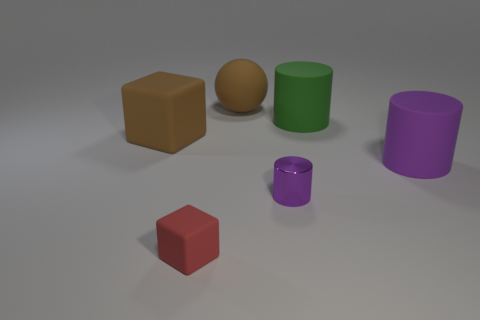Add 3 things. How many objects exist? 9 Subtract all cubes. How many objects are left? 4 Add 3 small blocks. How many small blocks exist? 4 Subtract 0 blue cubes. How many objects are left? 6 Subtract all tiny shiny cylinders. Subtract all large purple objects. How many objects are left? 4 Add 2 large rubber blocks. How many large rubber blocks are left? 3 